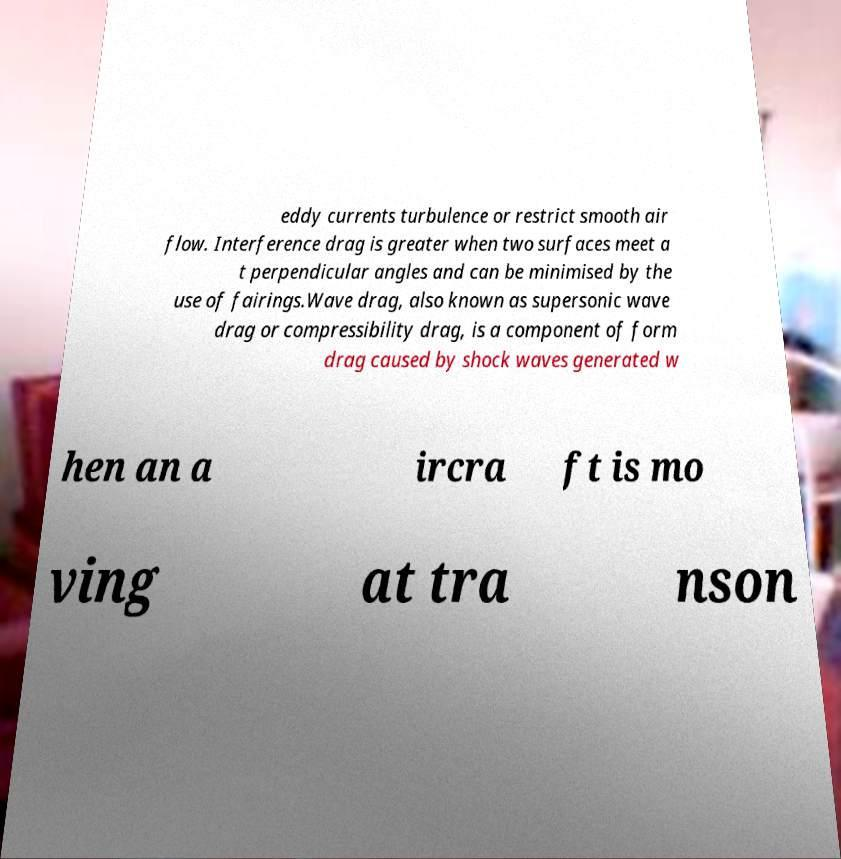Please identify and transcribe the text found in this image. eddy currents turbulence or restrict smooth air flow. Interference drag is greater when two surfaces meet a t perpendicular angles and can be minimised by the use of fairings.Wave drag, also known as supersonic wave drag or compressibility drag, is a component of form drag caused by shock waves generated w hen an a ircra ft is mo ving at tra nson 